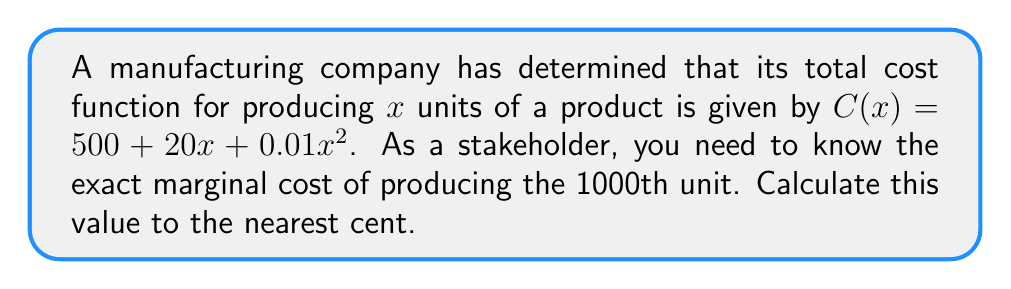Help me with this question. To solve this problem, we'll follow these steps:

1) The marginal cost is the derivative of the total cost function. Let's find $C'(x)$:

   $$C'(x) = \frac{d}{dx}(500 + 20x + 0.01x^2)$$
   $$C'(x) = 0 + 20 + 0.02x$$
   $$C'(x) = 20 + 0.02x$$

2) The marginal cost function $C'(x)$ gives us the cost of producing the next unit at any given production level x.

3) To find the marginal cost of the 1000th unit, we evaluate $C'(x)$ at $x = 1000$:

   $$C'(1000) = 20 + 0.02(1000)$$
   $$C'(1000) = 20 + 20$$
   $$C'(1000) = 40$$

4) Therefore, the marginal cost of producing the 1000th unit is $40.

5) Rounding to the nearest cent is not necessary in this case as the result is already a whole number of dollars.
Answer: $40 